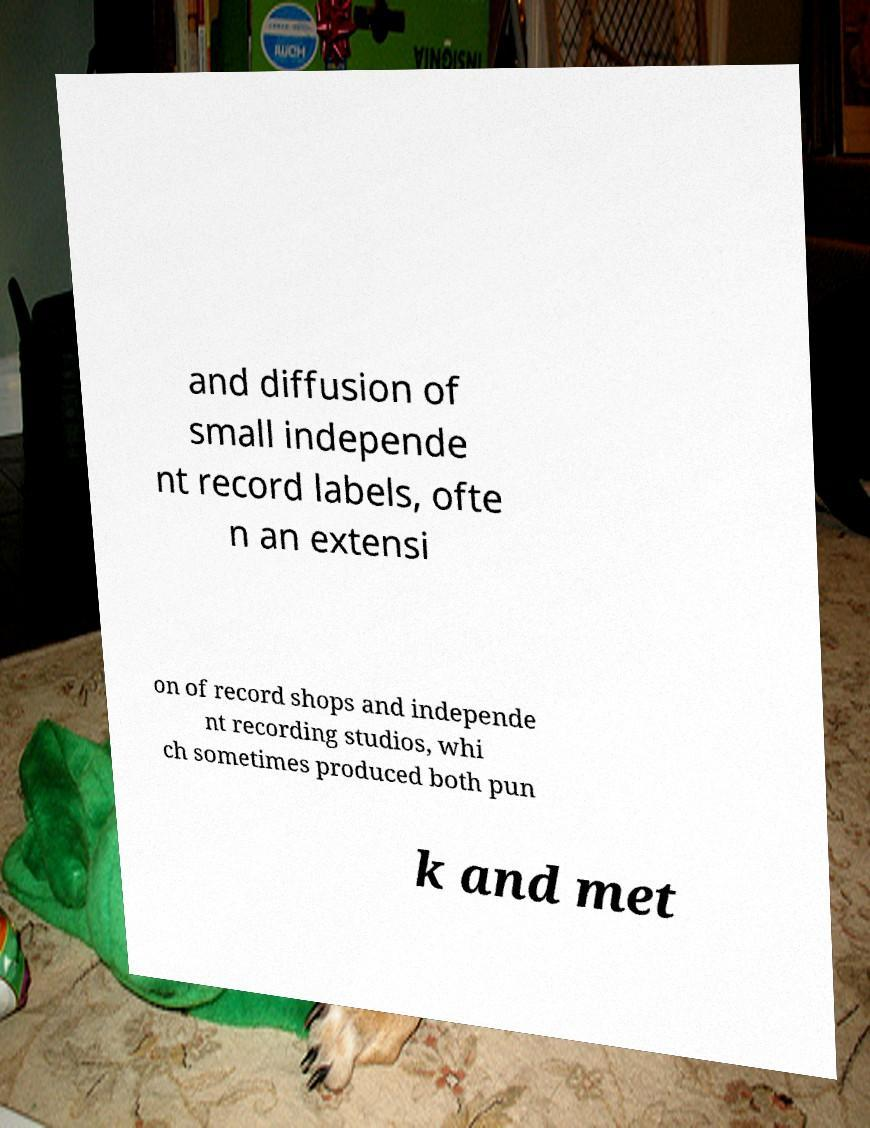Can you read and provide the text displayed in the image?This photo seems to have some interesting text. Can you extract and type it out for me? and diffusion of small independe nt record labels, ofte n an extensi on of record shops and independe nt recording studios, whi ch sometimes produced both pun k and met 